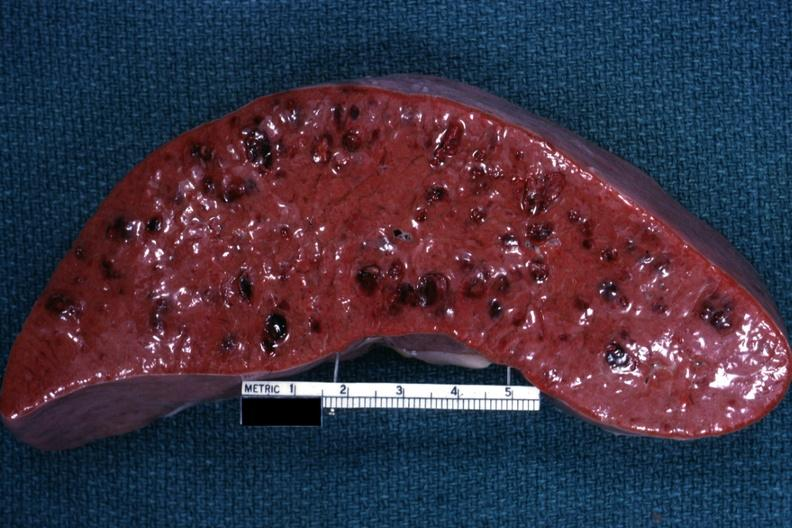what is present?
Answer the question using a single word or phrase. Spleen 